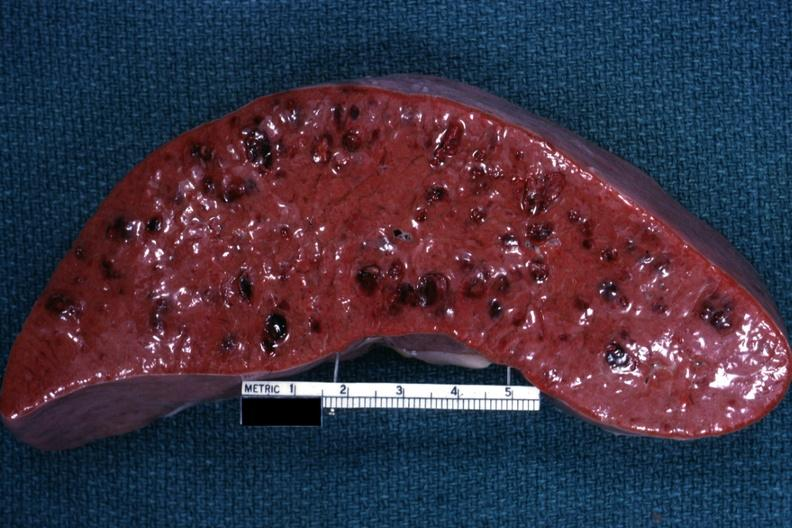what is present?
Answer the question using a single word or phrase. Spleen 